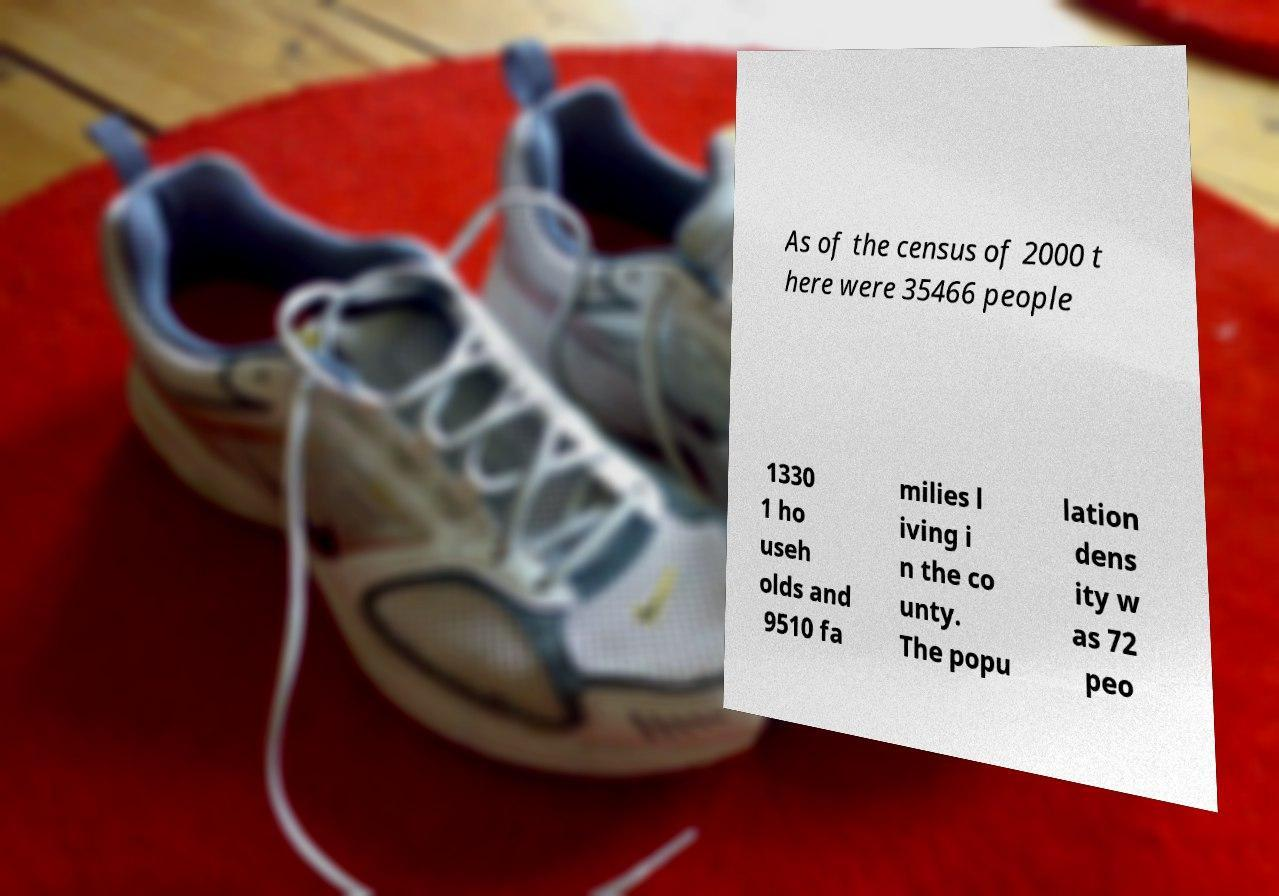Could you extract and type out the text from this image? As of the census of 2000 t here were 35466 people 1330 1 ho useh olds and 9510 fa milies l iving i n the co unty. The popu lation dens ity w as 72 peo 